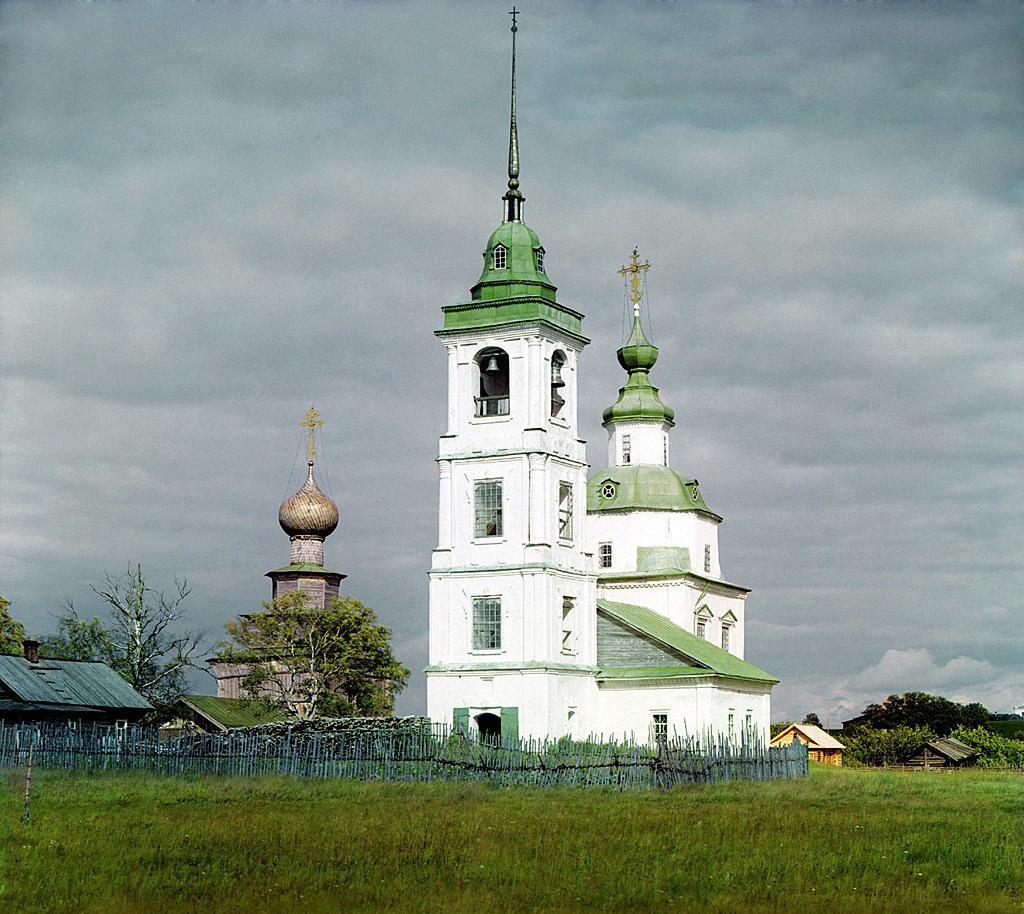Can you describe this image briefly? In this picture we can see there is a fence, grass, houses, buildings, trees and a cloudy sky. 